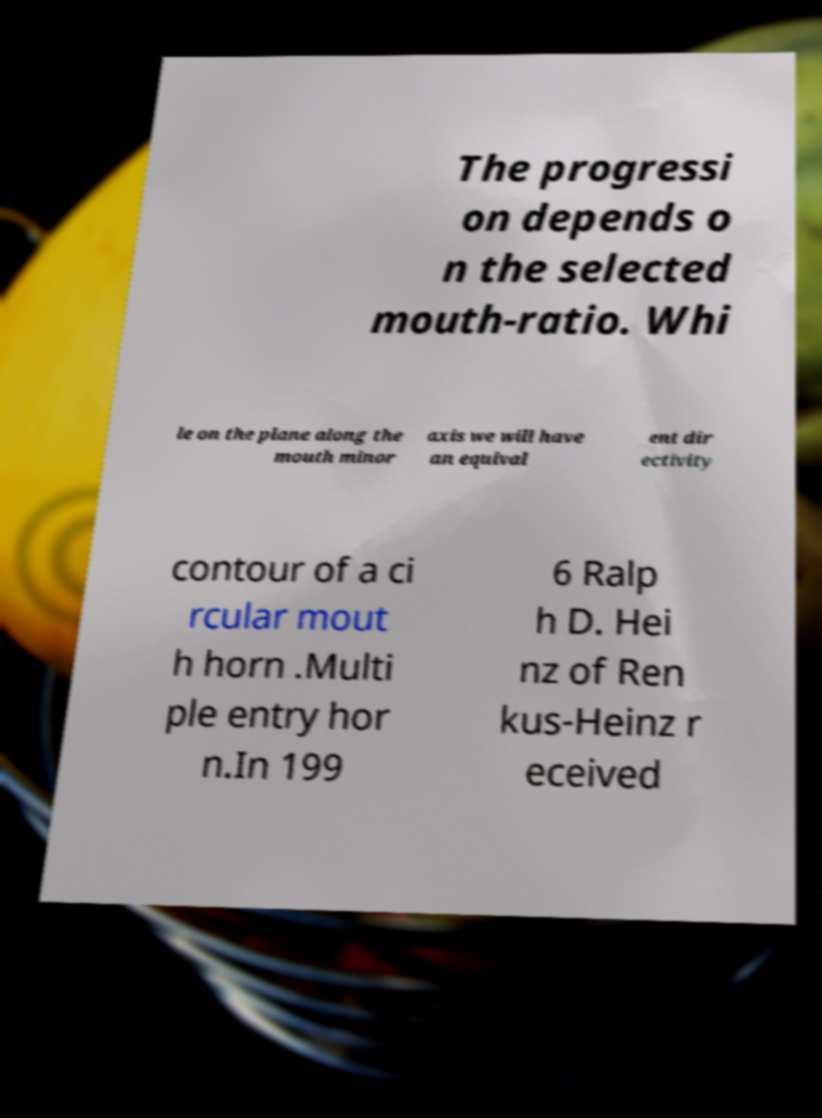Please read and relay the text visible in this image. What does it say? The progressi on depends o n the selected mouth-ratio. Whi le on the plane along the mouth minor axis we will have an equival ent dir ectivity contour of a ci rcular mout h horn .Multi ple entry hor n.In 199 6 Ralp h D. Hei nz of Ren kus-Heinz r eceived 